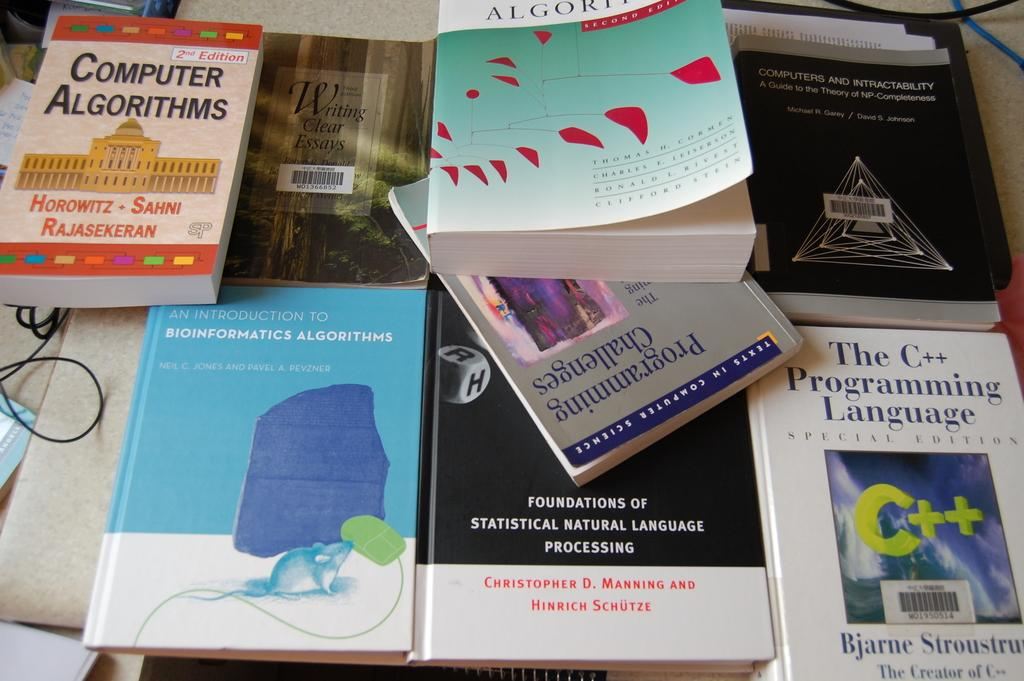Provide a one-sentence caption for the provided image. A book about computer algorithms has a classical style building on the cover. 